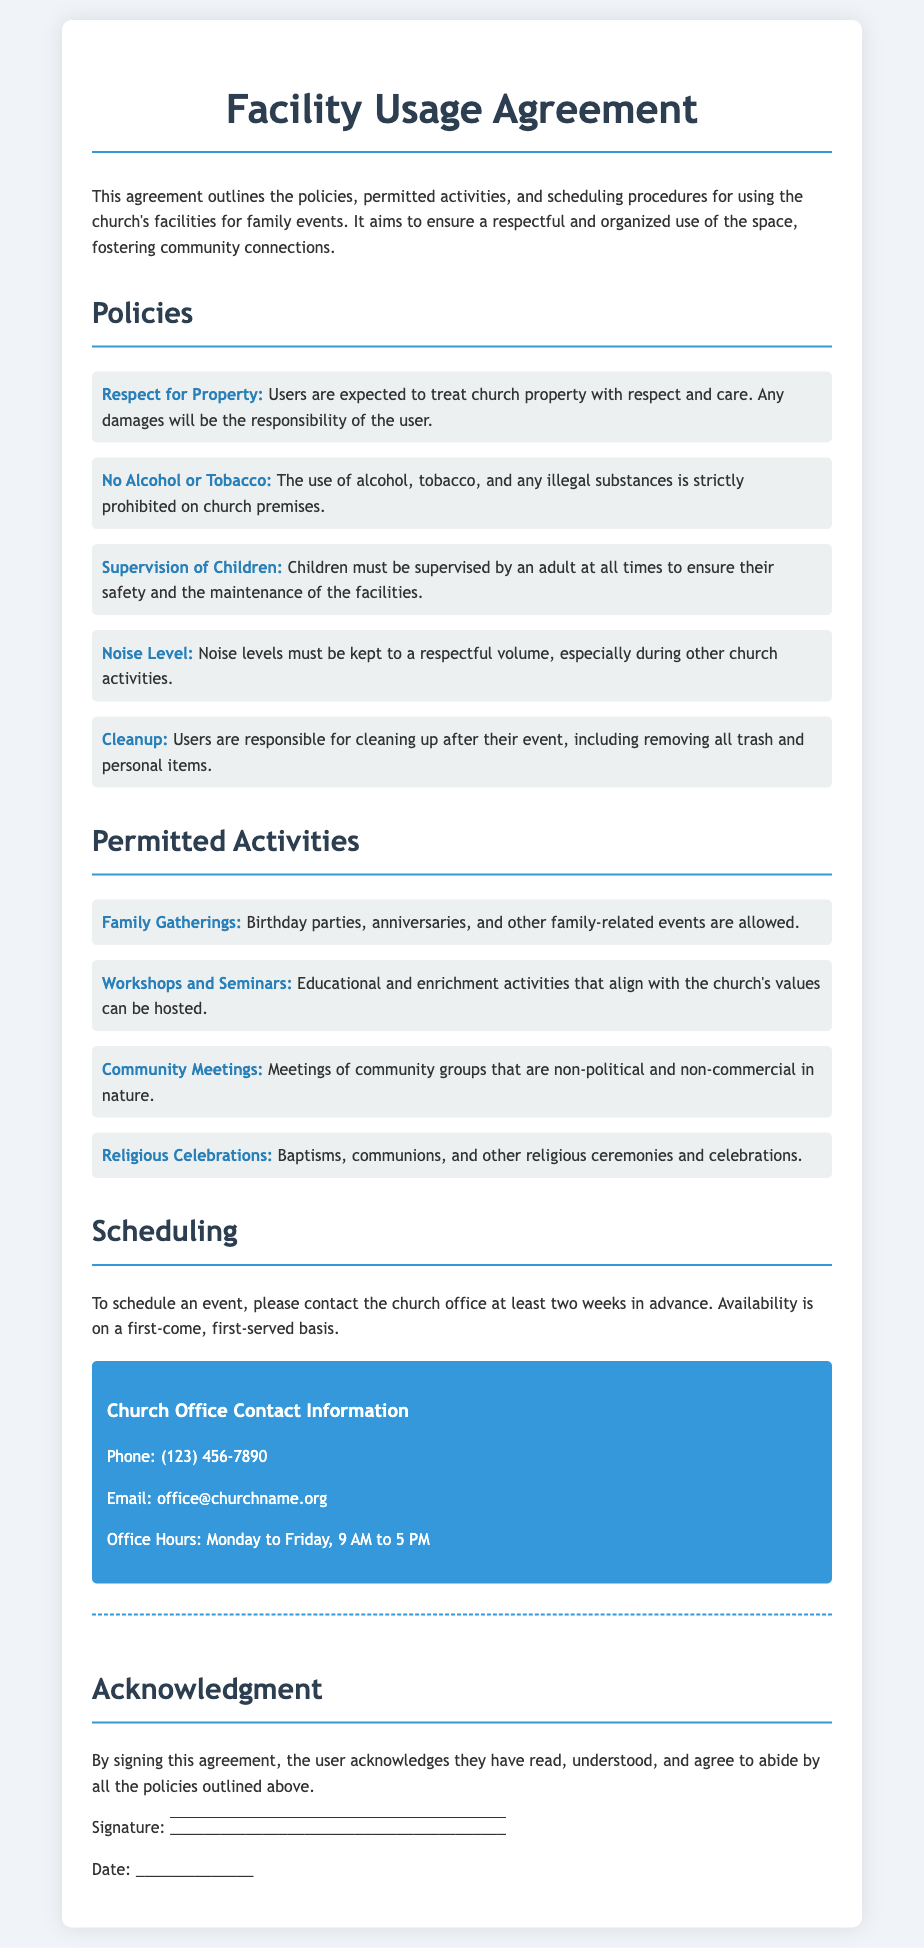what is the primary purpose of the agreement? The primary purpose is to outline policies, permitted activities, and scheduling procedures for using the church's facilities for family events.
Answer: to outline policies, permitted activities, and scheduling procedures what activities are explicitly prohibited on church premises? The document states that the use of alcohol, tobacco, and any illegal substances is strictly prohibited on church premises.
Answer: Alcohol, tobacco, and illegal substances how many weeks in advance should you contact the church office to schedule an event? The document specifies that you should contact the church office at least two weeks in advance to schedule an event.
Answer: two weeks who is responsible for cleaning up after an event? The agreement states that users are responsible for cleaning up after their event, including removing all trash and personal items.
Answer: Users can religious celebrations be held at the church? Yes, the agreement permits religious celebrations, including baptisms and communions.
Answer: Yes what is the contact phone number for the church office? The church office phone number provided in the document is (123) 456-7890.
Answer: (123) 456-7890 is supervision of children required according to the policies? Yes, children must be supervised by an adult at all times according to the document's policies.
Answer: Yes what types of community meetings are allowed at the church? The document permits community meetings that are non-political and non-commercial in nature.
Answer: Non-political and non-commercial 